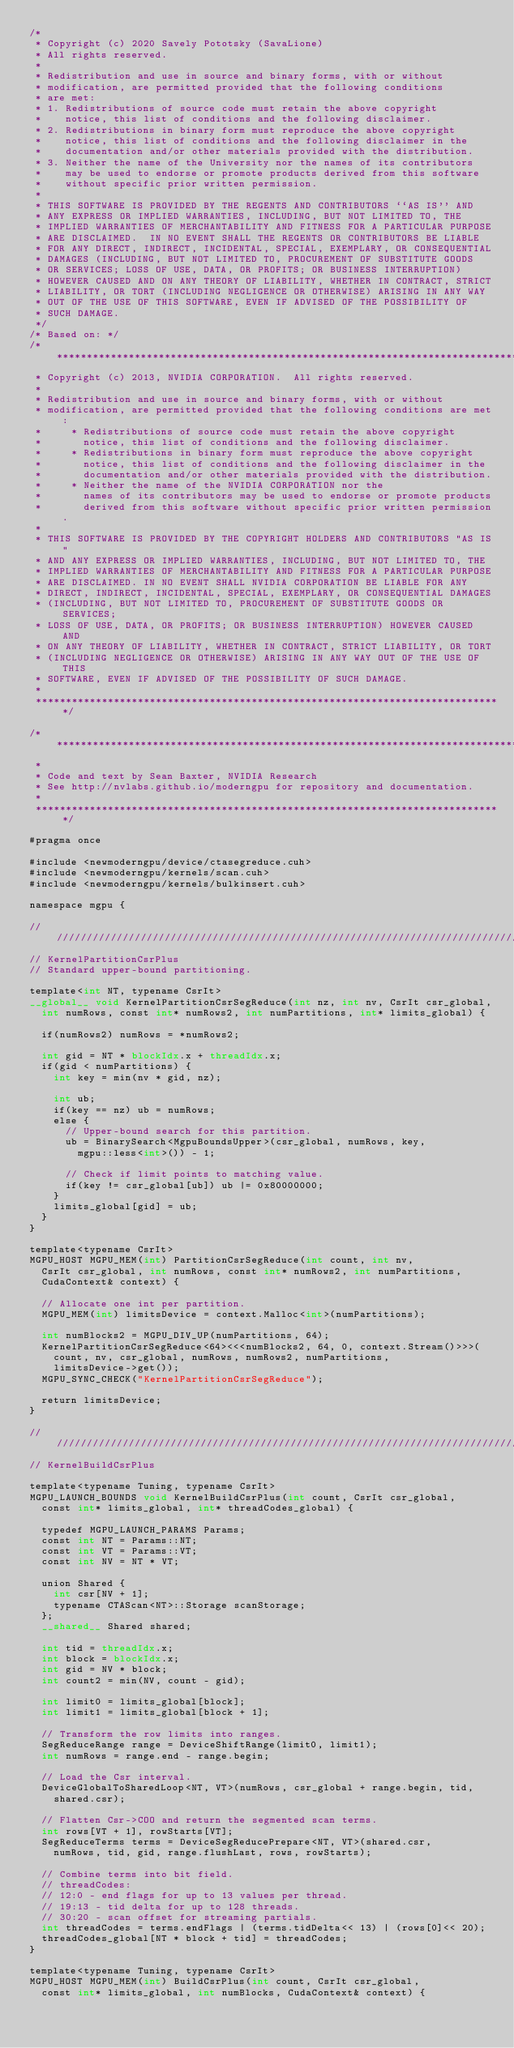<code> <loc_0><loc_0><loc_500><loc_500><_Cuda_>/*
 * Copyright (c) 2020 Savely Pototsky (SavaLione)
 * All rights reserved.
 *
 * Redistribution and use in source and binary forms, with or without
 * modification, are permitted provided that the following conditions
 * are met:
 * 1. Redistributions of source code must retain the above copyright
 *    notice, this list of conditions and the following disclaimer.
 * 2. Redistributions in binary form must reproduce the above copyright
 *    notice, this list of conditions and the following disclaimer in the
 *    documentation and/or other materials provided with the distribution.
 * 3. Neither the name of the University nor the names of its contributors
 *    may be used to endorse or promote products derived from this software
 *    without specific prior written permission.
 *
 * THIS SOFTWARE IS PROVIDED BY THE REGENTS AND CONTRIBUTORS ``AS IS'' AND
 * ANY EXPRESS OR IMPLIED WARRANTIES, INCLUDING, BUT NOT LIMITED TO, THE
 * IMPLIED WARRANTIES OF MERCHANTABILITY AND FITNESS FOR A PARTICULAR PURPOSE
 * ARE DISCLAIMED.  IN NO EVENT SHALL THE REGENTS OR CONTRIBUTORS BE LIABLE
 * FOR ANY DIRECT, INDIRECT, INCIDENTAL, SPECIAL, EXEMPLARY, OR CONSEQUENTIAL
 * DAMAGES (INCLUDING, BUT NOT LIMITED TO, PROCUREMENT OF SUBSTITUTE GOODS
 * OR SERVICES; LOSS OF USE, DATA, OR PROFITS; OR BUSINESS INTERRUPTION)
 * HOWEVER CAUSED AND ON ANY THEORY OF LIABILITY, WHETHER IN CONTRACT, STRICT
 * LIABILITY, OR TORT (INCLUDING NEGLIGENCE OR OTHERWISE) ARISING IN ANY WAY
 * OUT OF THE USE OF THIS SOFTWARE, EVEN IF ADVISED OF THE POSSIBILITY OF
 * SUCH DAMAGE.
 */
/* Based on: */
/******************************************************************************
 * Copyright (c) 2013, NVIDIA CORPORATION.  All rights reserved.
 * 
 * Redistribution and use in source and binary forms, with or without
 * modification, are permitted provided that the following conditions are met:
 *     * Redistributions of source code must retain the above copyright
 *       notice, this list of conditions and the following disclaimer.
 *     * Redistributions in binary form must reproduce the above copyright
 *       notice, this list of conditions and the following disclaimer in the
 *       documentation and/or other materials provided with the distribution.
 *     * Neither the name of the NVIDIA CORPORATION nor the
 *       names of its contributors may be used to endorse or promote products
 *       derived from this software without specific prior written permission.
 * 
 * THIS SOFTWARE IS PROVIDED BY THE COPYRIGHT HOLDERS AND CONTRIBUTORS "AS IS" 
 * AND ANY EXPRESS OR IMPLIED WARRANTIES, INCLUDING, BUT NOT LIMITED TO, THE
 * IMPLIED WARRANTIES OF MERCHANTABILITY AND FITNESS FOR A PARTICULAR PURPOSE 
 * ARE DISCLAIMED. IN NO EVENT SHALL NVIDIA CORPORATION BE LIABLE FOR ANY
 * DIRECT, INDIRECT, INCIDENTAL, SPECIAL, EXEMPLARY, OR CONSEQUENTIAL DAMAGES
 * (INCLUDING, BUT NOT LIMITED TO, PROCUREMENT OF SUBSTITUTE GOODS OR SERVICES;
 * LOSS OF USE, DATA, OR PROFITS; OR BUSINESS INTERRUPTION) HOWEVER CAUSED AND
 * ON ANY THEORY OF LIABILITY, WHETHER IN CONTRACT, STRICT LIABILITY, OR TORT
 * (INCLUDING NEGLIGENCE OR OTHERWISE) ARISING IN ANY WAY OUT OF THE USE OF THIS
 * SOFTWARE, EVEN IF ADVISED OF THE POSSIBILITY OF SUCH DAMAGE.
 *
 ******************************************************************************/

/******************************************************************************
 *
 * Code and text by Sean Baxter, NVIDIA Research
 * See http://nvlabs.github.io/moderngpu for repository and documentation.
 *
 ******************************************************************************/

#pragma once

#include <newmoderngpu/device/ctasegreduce.cuh>
#include <newmoderngpu/kernels/scan.cuh>
#include <newmoderngpu/kernels/bulkinsert.cuh>

namespace mgpu {

////////////////////////////////////////////////////////////////////////////////
// KernelPartitionCsrPlus
// Standard upper-bound partitioning.

template<int NT, typename CsrIt>
__global__ void KernelPartitionCsrSegReduce(int nz, int nv, CsrIt csr_global,
	int numRows, const int* numRows2, int numPartitions, int* limits_global) {
		
	if(numRows2) numRows = *numRows2;

	int gid = NT * blockIdx.x + threadIdx.x;
	if(gid < numPartitions) { 
		int key = min(nv * gid, nz);

		int ub;
		if(key == nz) ub = numRows;
		else {
			// Upper-bound search for this partition.
			ub = BinarySearch<MgpuBoundsUpper>(csr_global, numRows, key, 
				mgpu::less<int>()) - 1;

			// Check if limit points to matching value.
			if(key != csr_global[ub]) ub |= 0x80000000;
		}
		limits_global[gid] = ub;
	}
}

template<typename CsrIt>
MGPU_HOST MGPU_MEM(int) PartitionCsrSegReduce(int count, int nv,
	CsrIt csr_global, int numRows, const int* numRows2, int numPartitions, 
	CudaContext& context) {

	// Allocate one int per partition.
	MGPU_MEM(int) limitsDevice = context.Malloc<int>(numPartitions);

	int numBlocks2 = MGPU_DIV_UP(numPartitions, 64);
	KernelPartitionCsrSegReduce<64><<<numBlocks2, 64, 0, context.Stream()>>>(
		count, nv, csr_global, numRows, numRows2, numPartitions,
		limitsDevice->get());
	MGPU_SYNC_CHECK("KernelPartitionCsrSegReduce");

	return limitsDevice;
}

////////////////////////////////////////////////////////////////////////////////
// KernelBuildCsrPlus

template<typename Tuning, typename CsrIt>
MGPU_LAUNCH_BOUNDS void KernelBuildCsrPlus(int count, CsrIt csr_global,
	const int* limits_global, int* threadCodes_global) {

	typedef MGPU_LAUNCH_PARAMS Params;
	const int NT = Params::NT;
	const int VT = Params::VT;
	const int NV = NT * VT;

	union Shared {
		int csr[NV + 1];
		typename CTAScan<NT>::Storage scanStorage;
	};
	__shared__ Shared shared;

	int tid = threadIdx.x;
	int block = blockIdx.x;
	int gid = NV * block;
	int count2 = min(NV, count - gid);

	int limit0 = limits_global[block];
	int limit1 = limits_global[block + 1];

	// Transform the row limits into ranges.
	SegReduceRange range = DeviceShiftRange(limit0, limit1);
	int numRows = range.end - range.begin;

	// Load the Csr interval.
	DeviceGlobalToSharedLoop<NT, VT>(numRows, csr_global + range.begin, tid, 
		shared.csr);

	// Flatten Csr->COO and return the segmented scan terms.
	int rows[VT + 1], rowStarts[VT];
	SegReduceTerms terms = DeviceSegReducePrepare<NT, VT>(shared.csr, 
		numRows, tid, gid, range.flushLast, rows, rowStarts);
	
	// Combine terms into bit field.
	// threadCodes:
	// 12:0 - end flags for up to 13 values per thread.
	// 19:13 - tid delta for up to 128 threads.
	// 30:20 - scan offset for streaming partials.
	int threadCodes = terms.endFlags | (terms.tidDelta<< 13) | (rows[0]<< 20);
	threadCodes_global[NT * block + tid] = threadCodes;
}

template<typename Tuning, typename CsrIt>
MGPU_HOST MGPU_MEM(int) BuildCsrPlus(int count, CsrIt csr_global, 
	const int* limits_global, int numBlocks, CudaContext& context) {
</code> 